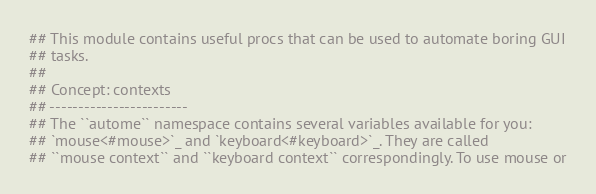<code> <loc_0><loc_0><loc_500><loc_500><_Nim_>## This module contains useful procs that can be used to automate boring GUI
## tasks.
##
## Concept: contexts
## ------------------------
## The ``autome`` namespace contains several variables available for you:
## `mouse<#mouse>`_ and `keyboard<#keyboard>`_. They are called
## ``mouse context`` and ``keyboard context`` correspondingly. To use mouse or</code> 